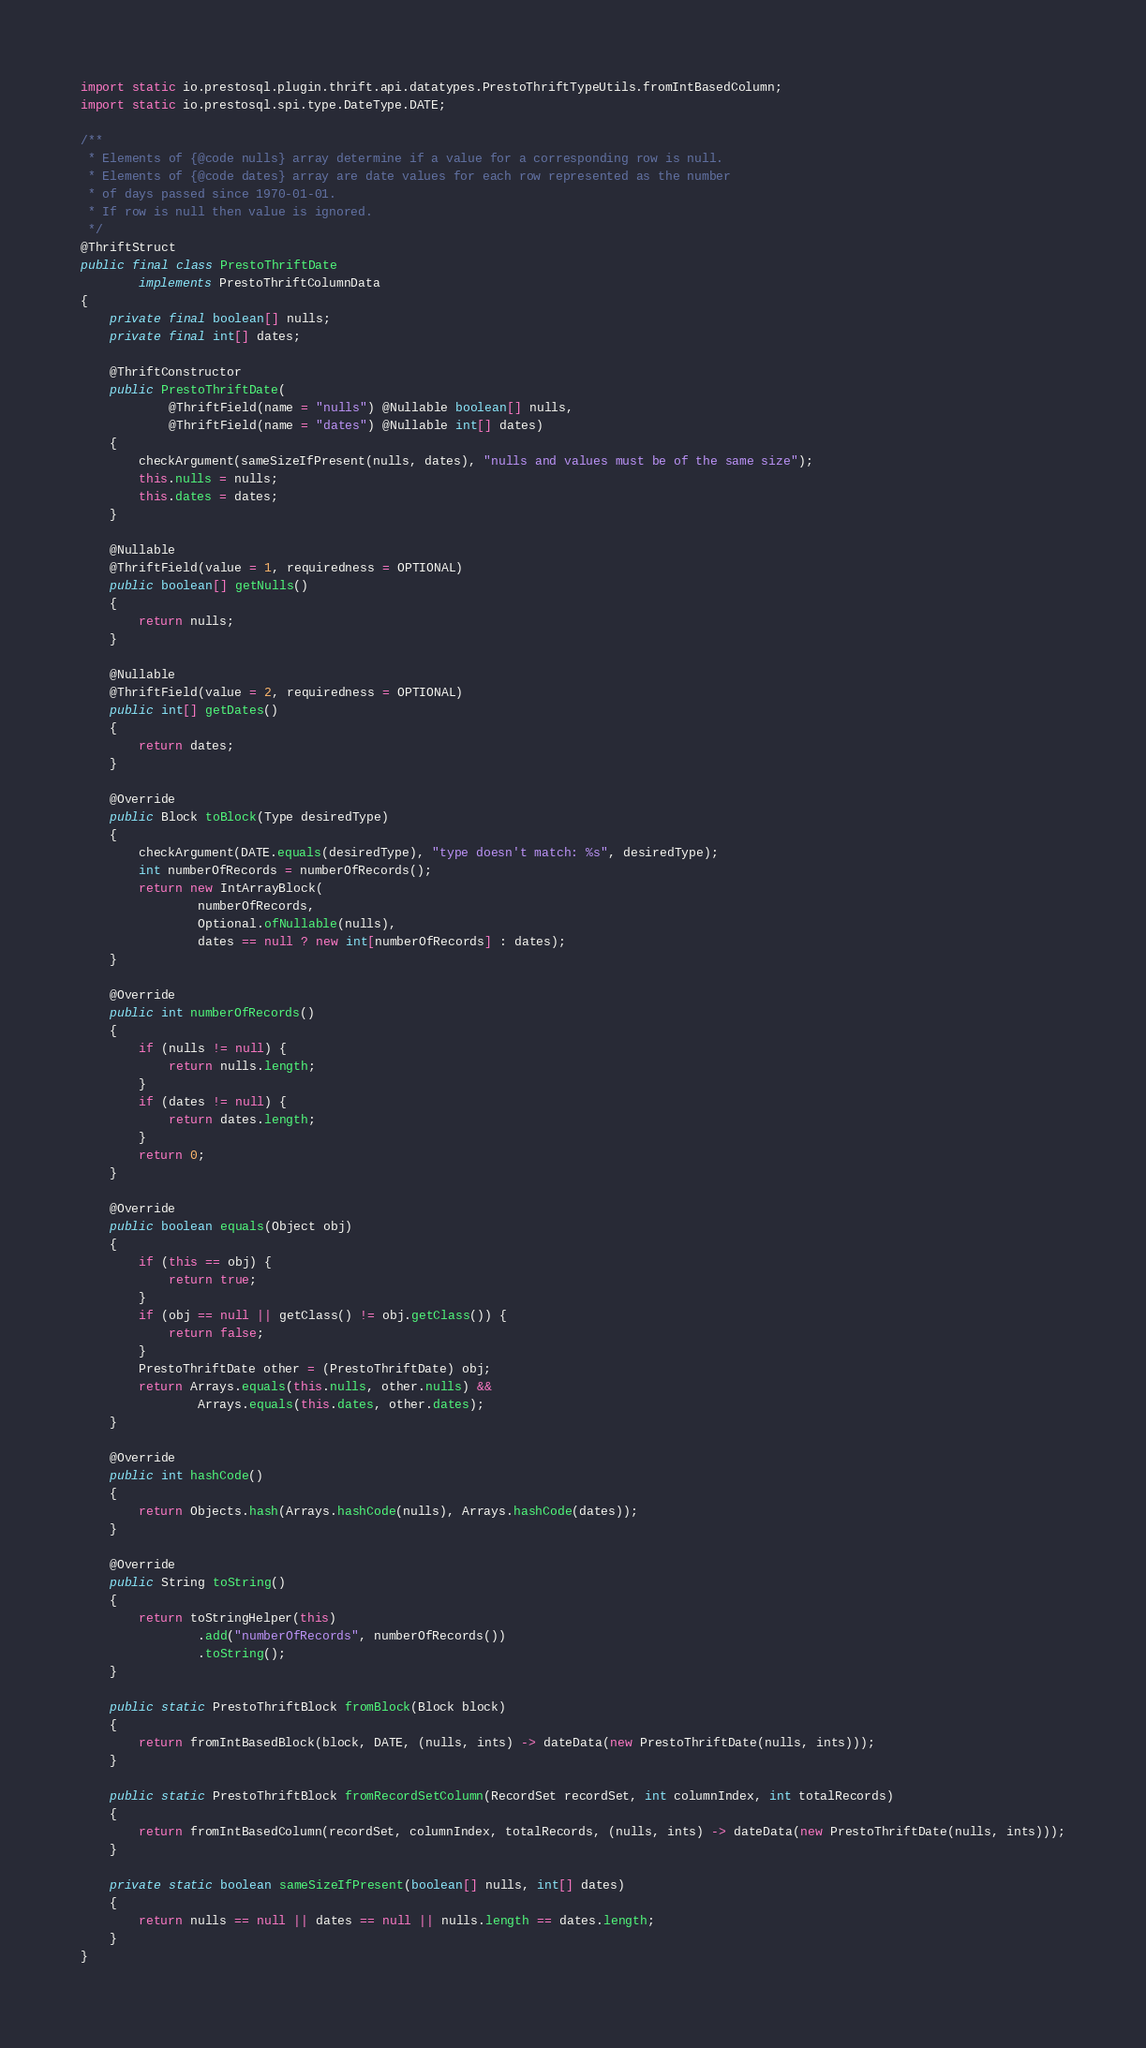<code> <loc_0><loc_0><loc_500><loc_500><_Java_>import static io.prestosql.plugin.thrift.api.datatypes.PrestoThriftTypeUtils.fromIntBasedColumn;
import static io.prestosql.spi.type.DateType.DATE;

/**
 * Elements of {@code nulls} array determine if a value for a corresponding row is null.
 * Elements of {@code dates} array are date values for each row represented as the number
 * of days passed since 1970-01-01.
 * If row is null then value is ignored.
 */
@ThriftStruct
public final class PrestoThriftDate
        implements PrestoThriftColumnData
{
    private final boolean[] nulls;
    private final int[] dates;

    @ThriftConstructor
    public PrestoThriftDate(
            @ThriftField(name = "nulls") @Nullable boolean[] nulls,
            @ThriftField(name = "dates") @Nullable int[] dates)
    {
        checkArgument(sameSizeIfPresent(nulls, dates), "nulls and values must be of the same size");
        this.nulls = nulls;
        this.dates = dates;
    }

    @Nullable
    @ThriftField(value = 1, requiredness = OPTIONAL)
    public boolean[] getNulls()
    {
        return nulls;
    }

    @Nullable
    @ThriftField(value = 2, requiredness = OPTIONAL)
    public int[] getDates()
    {
        return dates;
    }

    @Override
    public Block toBlock(Type desiredType)
    {
        checkArgument(DATE.equals(desiredType), "type doesn't match: %s", desiredType);
        int numberOfRecords = numberOfRecords();
        return new IntArrayBlock(
                numberOfRecords,
                Optional.ofNullable(nulls),
                dates == null ? new int[numberOfRecords] : dates);
    }

    @Override
    public int numberOfRecords()
    {
        if (nulls != null) {
            return nulls.length;
        }
        if (dates != null) {
            return dates.length;
        }
        return 0;
    }

    @Override
    public boolean equals(Object obj)
    {
        if (this == obj) {
            return true;
        }
        if (obj == null || getClass() != obj.getClass()) {
            return false;
        }
        PrestoThriftDate other = (PrestoThriftDate) obj;
        return Arrays.equals(this.nulls, other.nulls) &&
                Arrays.equals(this.dates, other.dates);
    }

    @Override
    public int hashCode()
    {
        return Objects.hash(Arrays.hashCode(nulls), Arrays.hashCode(dates));
    }

    @Override
    public String toString()
    {
        return toStringHelper(this)
                .add("numberOfRecords", numberOfRecords())
                .toString();
    }

    public static PrestoThriftBlock fromBlock(Block block)
    {
        return fromIntBasedBlock(block, DATE, (nulls, ints) -> dateData(new PrestoThriftDate(nulls, ints)));
    }

    public static PrestoThriftBlock fromRecordSetColumn(RecordSet recordSet, int columnIndex, int totalRecords)
    {
        return fromIntBasedColumn(recordSet, columnIndex, totalRecords, (nulls, ints) -> dateData(new PrestoThriftDate(nulls, ints)));
    }

    private static boolean sameSizeIfPresent(boolean[] nulls, int[] dates)
    {
        return nulls == null || dates == null || nulls.length == dates.length;
    }
}
</code> 